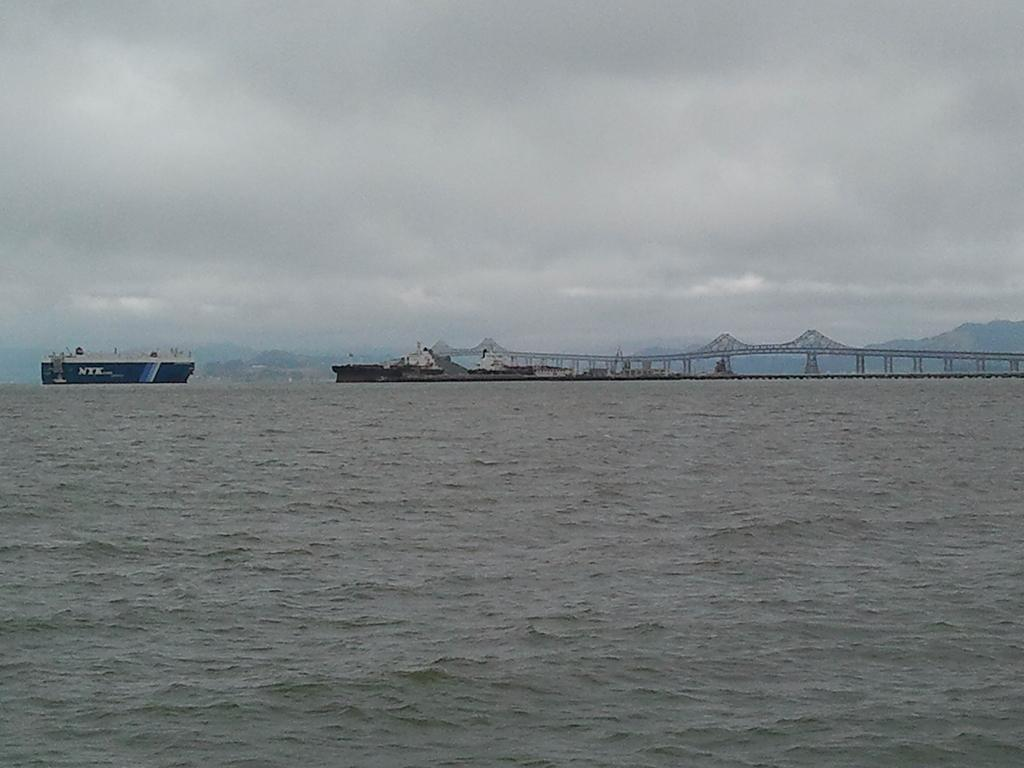What is at the bottom of the image? There is water at the bottom of the image. What is in the water? There is a ship in the water. What can be seen in the background of the image? There is a bridge in the background of the image. What is visible at the top of the image? The sky is visible at the top of the image. How does the stream flow through the image? There is no stream present in the image; it features water, a ship, a bridge, and the sky. What rule is being enforced by the ship in the image? There is no indication of any rules being enforced by the ship in the image. 